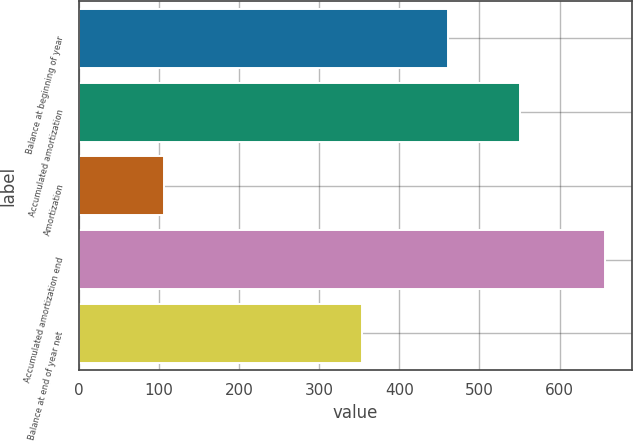Convert chart. <chart><loc_0><loc_0><loc_500><loc_500><bar_chart><fcel>Balance at beginning of year<fcel>Accumulated amortization<fcel>Amortization<fcel>Accumulated amortization end<fcel>Balance at end of year net<nl><fcel>461<fcel>550<fcel>107<fcel>657<fcel>354<nl></chart> 